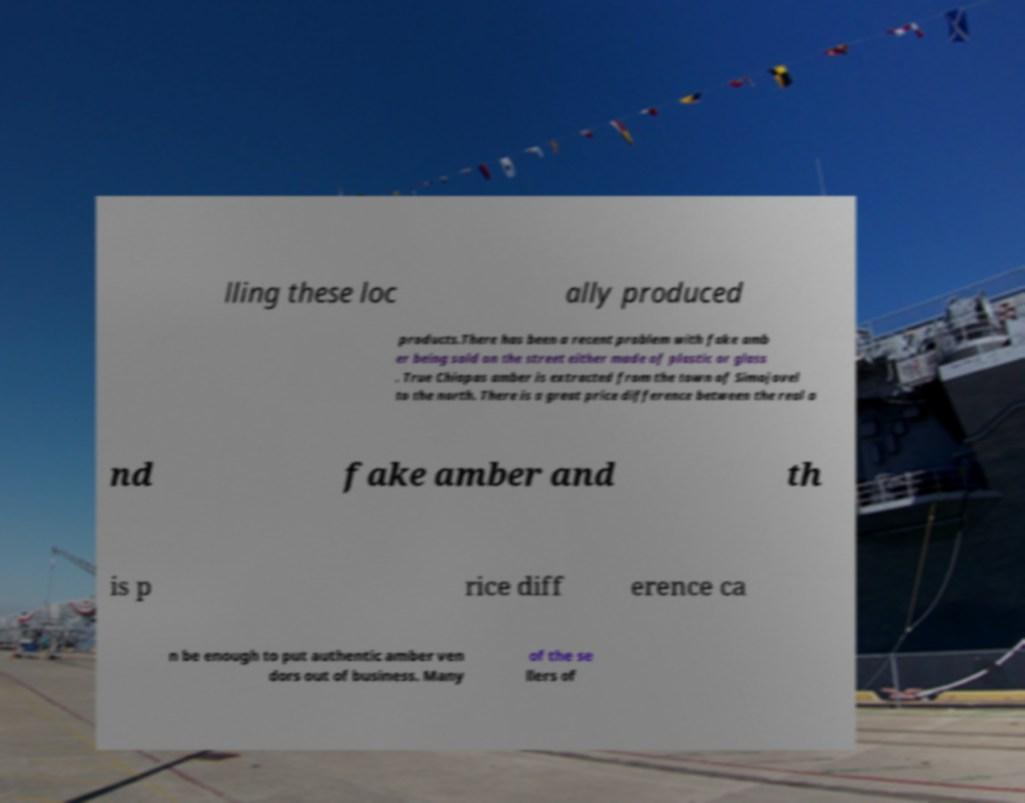Please identify and transcribe the text found in this image. lling these loc ally produced products.There has been a recent problem with fake amb er being sold on the street either made of plastic or glass . True Chiapas amber is extracted from the town of Simojovel to the north. There is a great price difference between the real a nd fake amber and th is p rice diff erence ca n be enough to put authentic amber ven dors out of business. Many of the se llers of 